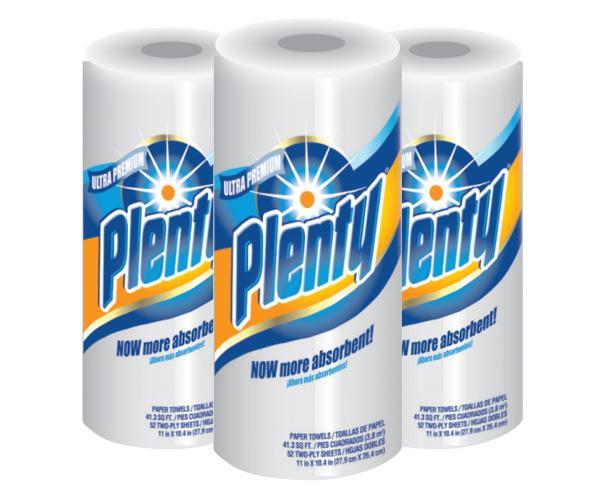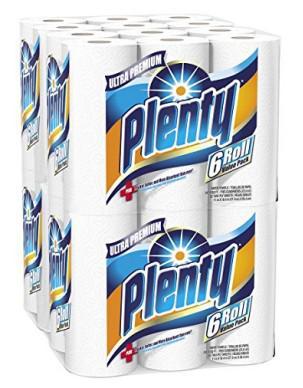The first image is the image on the left, the second image is the image on the right. Examine the images to the left and right. Is the description "There is exactly one paper towel roll in the left image" accurate? Answer yes or no. No. The first image is the image on the left, the second image is the image on the right. Analyze the images presented: Is the assertion "One image shows at least one six-roll multipack of paper towels." valid? Answer yes or no. Yes. 